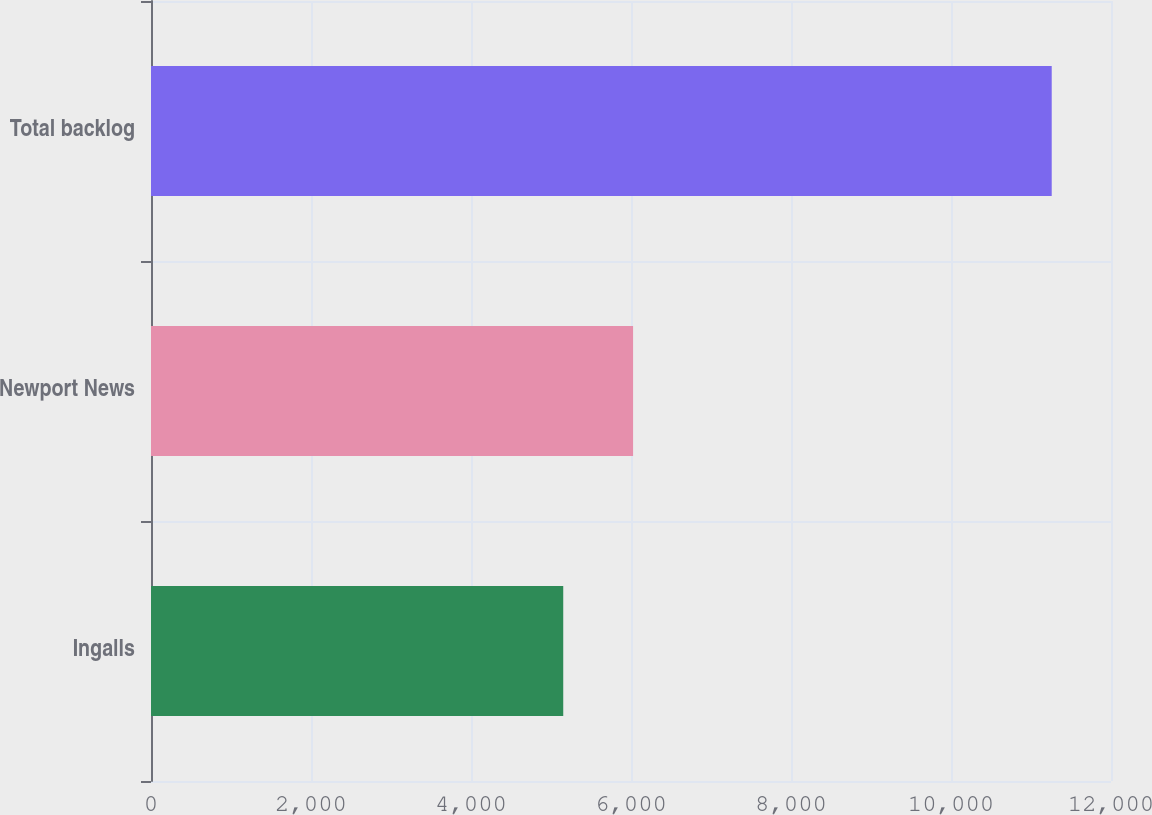<chart> <loc_0><loc_0><loc_500><loc_500><bar_chart><fcel>Ingalls<fcel>Newport News<fcel>Total backlog<nl><fcel>5153<fcel>6026<fcel>11259<nl></chart> 